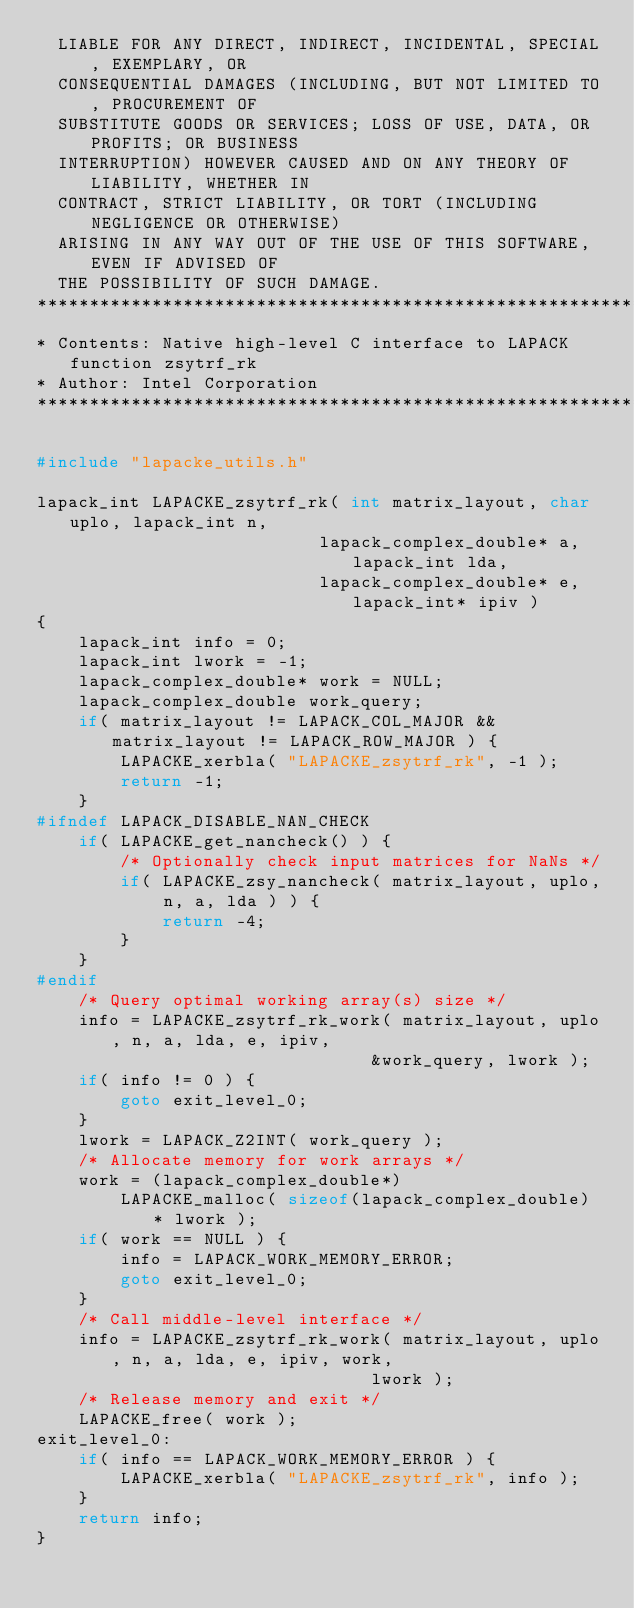Convert code to text. <code><loc_0><loc_0><loc_500><loc_500><_C_>  LIABLE FOR ANY DIRECT, INDIRECT, INCIDENTAL, SPECIAL, EXEMPLARY, OR
  CONSEQUENTIAL DAMAGES (INCLUDING, BUT NOT LIMITED TO, PROCUREMENT OF
  SUBSTITUTE GOODS OR SERVICES; LOSS OF USE, DATA, OR PROFITS; OR BUSINESS
  INTERRUPTION) HOWEVER CAUSED AND ON ANY THEORY OF LIABILITY, WHETHER IN
  CONTRACT, STRICT LIABILITY, OR TORT (INCLUDING NEGLIGENCE OR OTHERWISE)
  ARISING IN ANY WAY OUT OF THE USE OF THIS SOFTWARE, EVEN IF ADVISED OF
  THE POSSIBILITY OF SUCH DAMAGE.
*****************************************************************************
* Contents: Native high-level C interface to LAPACK function zsytrf_rk
* Author: Intel Corporation
*****************************************************************************/

#include "lapacke_utils.h"

lapack_int LAPACKE_zsytrf_rk( int matrix_layout, char uplo, lapack_int n,
                           lapack_complex_double* a, lapack_int lda,
                           lapack_complex_double* e, lapack_int* ipiv )
{
    lapack_int info = 0;
    lapack_int lwork = -1;
    lapack_complex_double* work = NULL;
    lapack_complex_double work_query;
    if( matrix_layout != LAPACK_COL_MAJOR && matrix_layout != LAPACK_ROW_MAJOR ) {
        LAPACKE_xerbla( "LAPACKE_zsytrf_rk", -1 );
        return -1;
    }
#ifndef LAPACK_DISABLE_NAN_CHECK
    if( LAPACKE_get_nancheck() ) {
        /* Optionally check input matrices for NaNs */
        if( LAPACKE_zsy_nancheck( matrix_layout, uplo, n, a, lda ) ) {
            return -4;
        }
    }
#endif
    /* Query optimal working array(s) size */
    info = LAPACKE_zsytrf_rk_work( matrix_layout, uplo, n, a, lda, e, ipiv,
                                &work_query, lwork );
    if( info != 0 ) {
        goto exit_level_0;
    }
    lwork = LAPACK_Z2INT( work_query );
    /* Allocate memory for work arrays */
    work = (lapack_complex_double*)
        LAPACKE_malloc( sizeof(lapack_complex_double) * lwork );
    if( work == NULL ) {
        info = LAPACK_WORK_MEMORY_ERROR;
        goto exit_level_0;
    }
    /* Call middle-level interface */
    info = LAPACKE_zsytrf_rk_work( matrix_layout, uplo, n, a, lda, e, ipiv, work,
                                lwork );
    /* Release memory and exit */
    LAPACKE_free( work );
exit_level_0:
    if( info == LAPACK_WORK_MEMORY_ERROR ) {
        LAPACKE_xerbla( "LAPACKE_zsytrf_rk", info );
    }
    return info;
}
</code> 